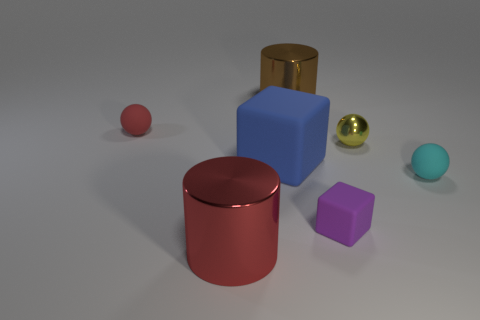Add 2 brown cylinders. How many objects exist? 9 Subtract all cylinders. How many objects are left? 5 Add 3 small yellow shiny objects. How many small yellow shiny objects exist? 4 Subtract 1 purple cubes. How many objects are left? 6 Subtract all rubber cubes. Subtract all big cyan spheres. How many objects are left? 5 Add 7 large blocks. How many large blocks are left? 8 